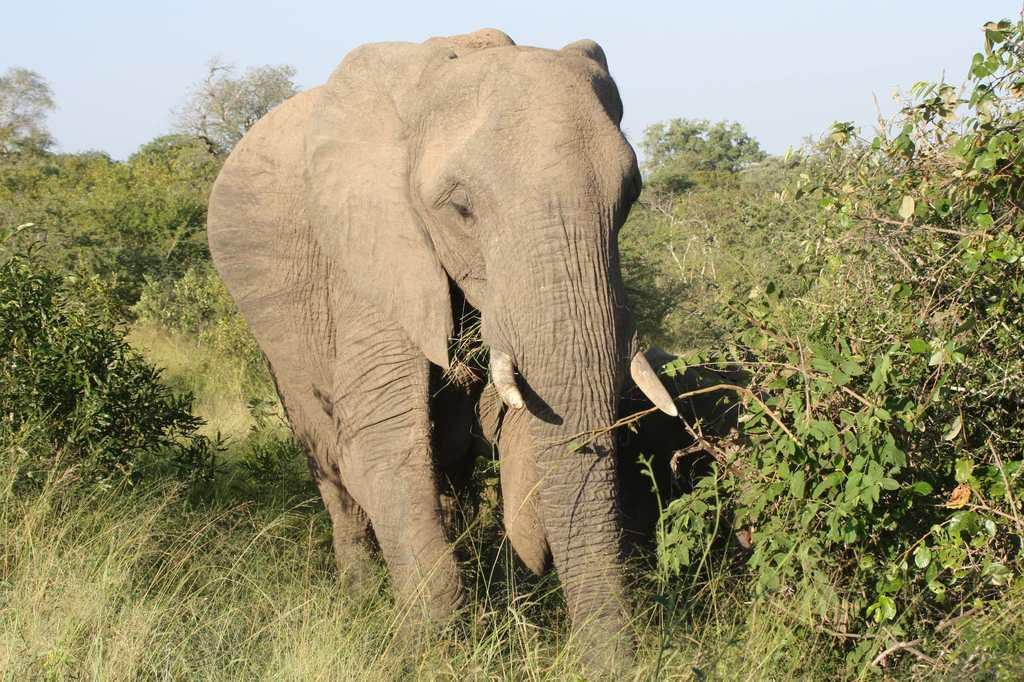What animal is the main subject of the image? There is an elephant in the image. What is the elephant doing in the image? The elephant is walking in the image. Where is the elephant located? The elephant is in a forest in the image. What can be seen in the background of the image? There are trees and a clear sky visible in the background of the image. What type of pancake is the elephant holding in the image? There is no pancake present in the image, and the elephant is not holding anything. 